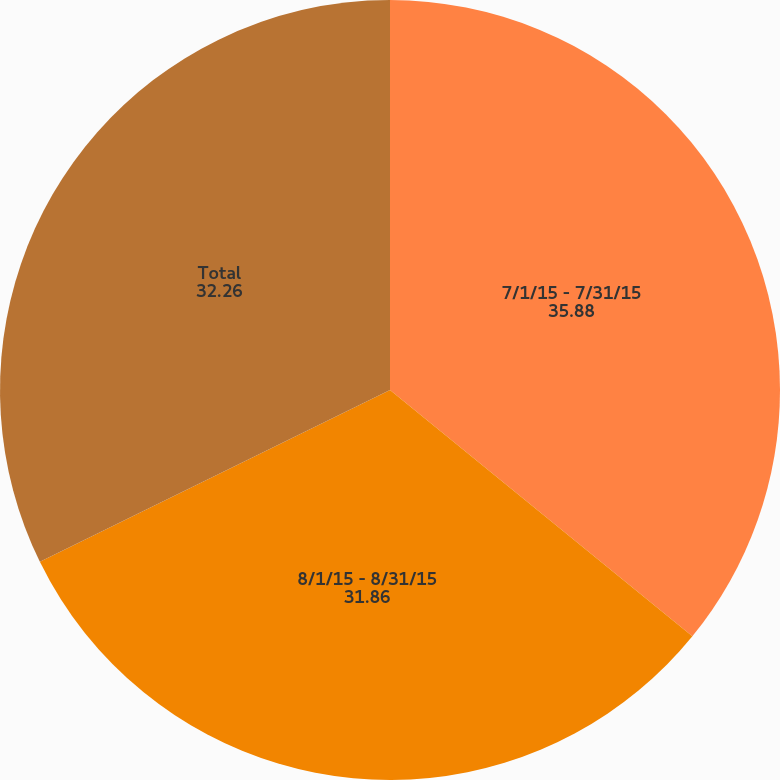Convert chart to OTSL. <chart><loc_0><loc_0><loc_500><loc_500><pie_chart><fcel>7/1/15 - 7/31/15<fcel>8/1/15 - 8/31/15<fcel>Total<nl><fcel>35.88%<fcel>31.86%<fcel>32.26%<nl></chart> 